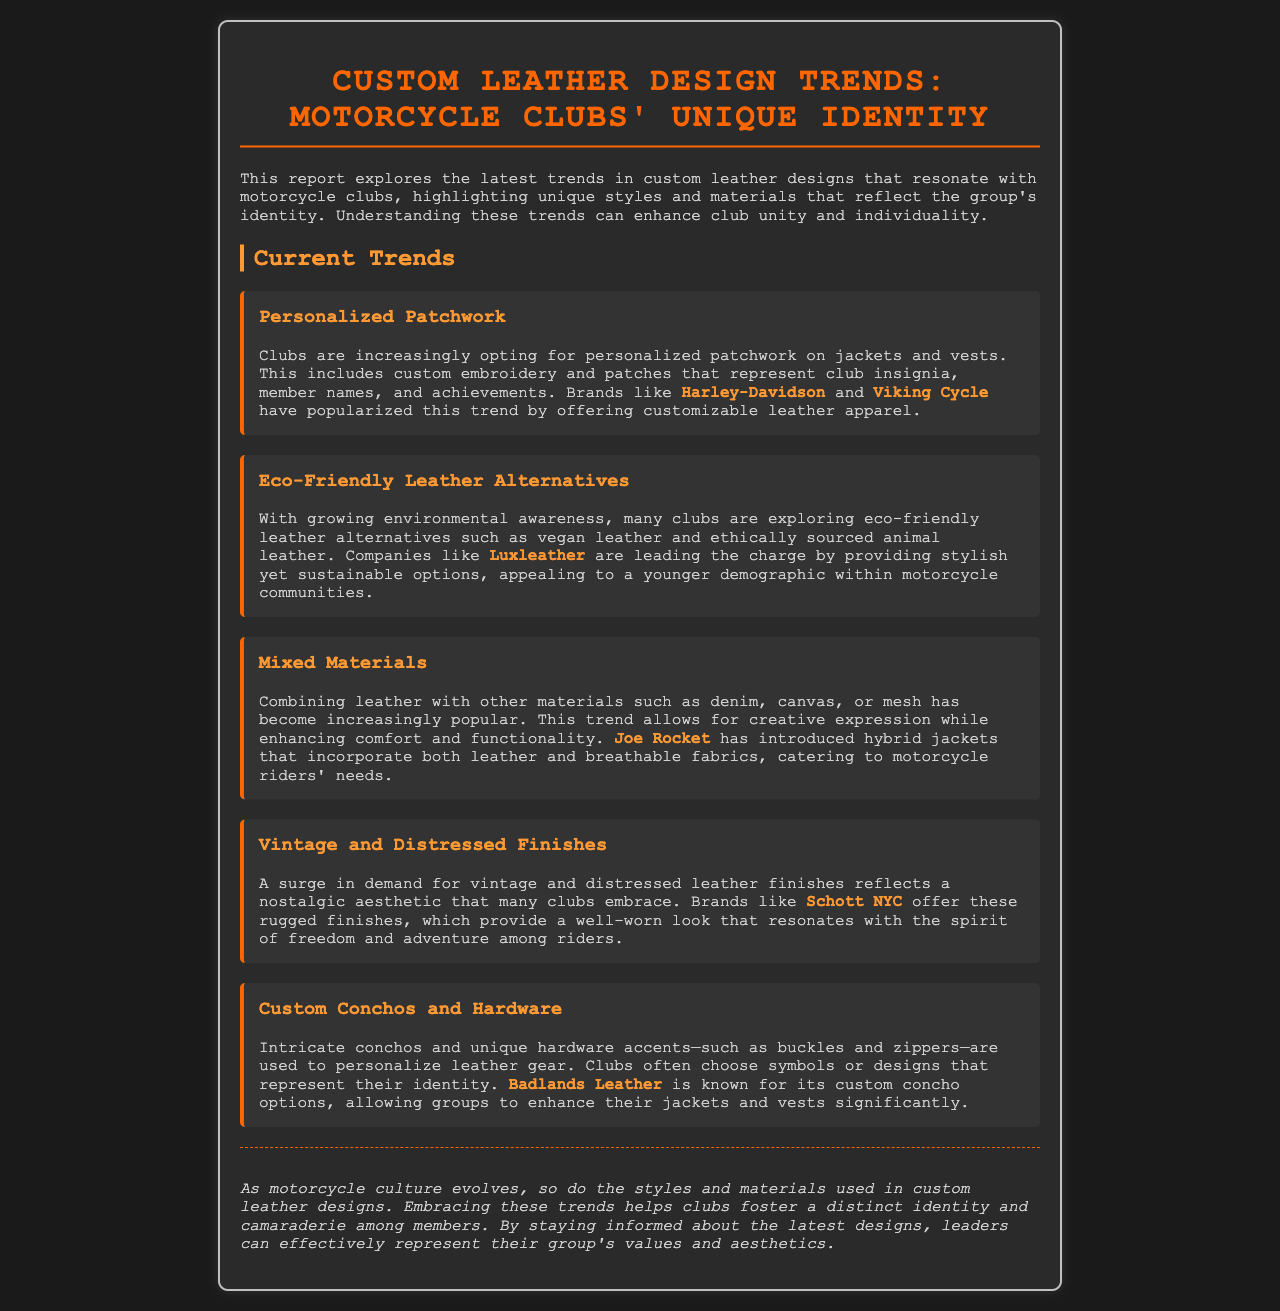What trend involves custom embroidery on jackets? The trend that involves custom embroidery on jackets is explained in the "Personalized Patchwork" section, highlighting its importance for club insignia and member names.
Answer: Personalized Patchwork Which brand leads in eco-friendly leather alternatives? The document states that companies like Luxleather are leading the charge in providing stylish yet sustainable options for eco-friendly leather alternatives.
Answer: Luxleather What type of finishes are currently in demand for leather? The report mentions that there is a surge in demand for vintage and distressed leather finishes among motorcycle clubs, reflecting a nostalgic aesthetic.
Answer: Vintage and Distressed Finishes What is one objective of combining leather with other materials? The reasoning in the document suggests that combining leather with other materials enhances comfort and functionality, fostering creative expression among riders.
Answer: Comfort and functionality Which company is known for custom concho options? The report specifically mentions Badlands Leather as a notable provider of custom concho options for personalizing leather gear.
Answer: Badlands Leather What does the conclusion propose for motorcycle clubs? The conclusion suggests that embracing the latest trends helps clubs foster a distinct identity and camaraderie among members, which aligns with the purpose of the report.
Answer: Distinct identity and camaraderie How do motorcycle clubs personalize their leather gear? The document describes that motorcycle clubs personalize their leather gear by using intricate conchos and unique hardware accents that represent their identity.
Answer: Unique hardware accents What does mixed materials combine with leather? The document explains that mixed materials can include denim, canvas, or mesh when combined with leather, allowing for greater creativity in design.
Answer: Denim, canvas, or mesh How does vintage leather resonate with motorcycle culture? The report indicates that the vintage and distressed finishes resonate with the spirit of freedom and adventure, appealing to many club members.
Answer: Freedom and adventure 